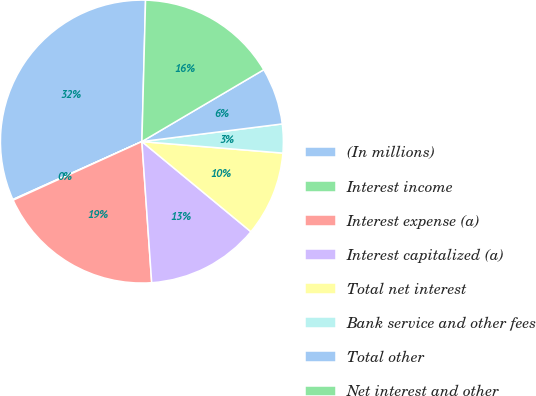Convert chart to OTSL. <chart><loc_0><loc_0><loc_500><loc_500><pie_chart><fcel>(In millions)<fcel>Interest income<fcel>Interest expense (a)<fcel>Interest capitalized (a)<fcel>Total net interest<fcel>Bank service and other fees<fcel>Total other<fcel>Net interest and other<nl><fcel>32.13%<fcel>0.08%<fcel>19.31%<fcel>12.9%<fcel>9.7%<fcel>3.29%<fcel>6.49%<fcel>16.11%<nl></chart> 